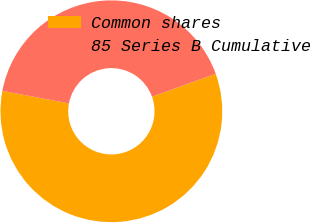Convert chart to OTSL. <chart><loc_0><loc_0><loc_500><loc_500><pie_chart><fcel>Common shares<fcel>85 Series B Cumulative<nl><fcel>58.43%<fcel>41.57%<nl></chart> 